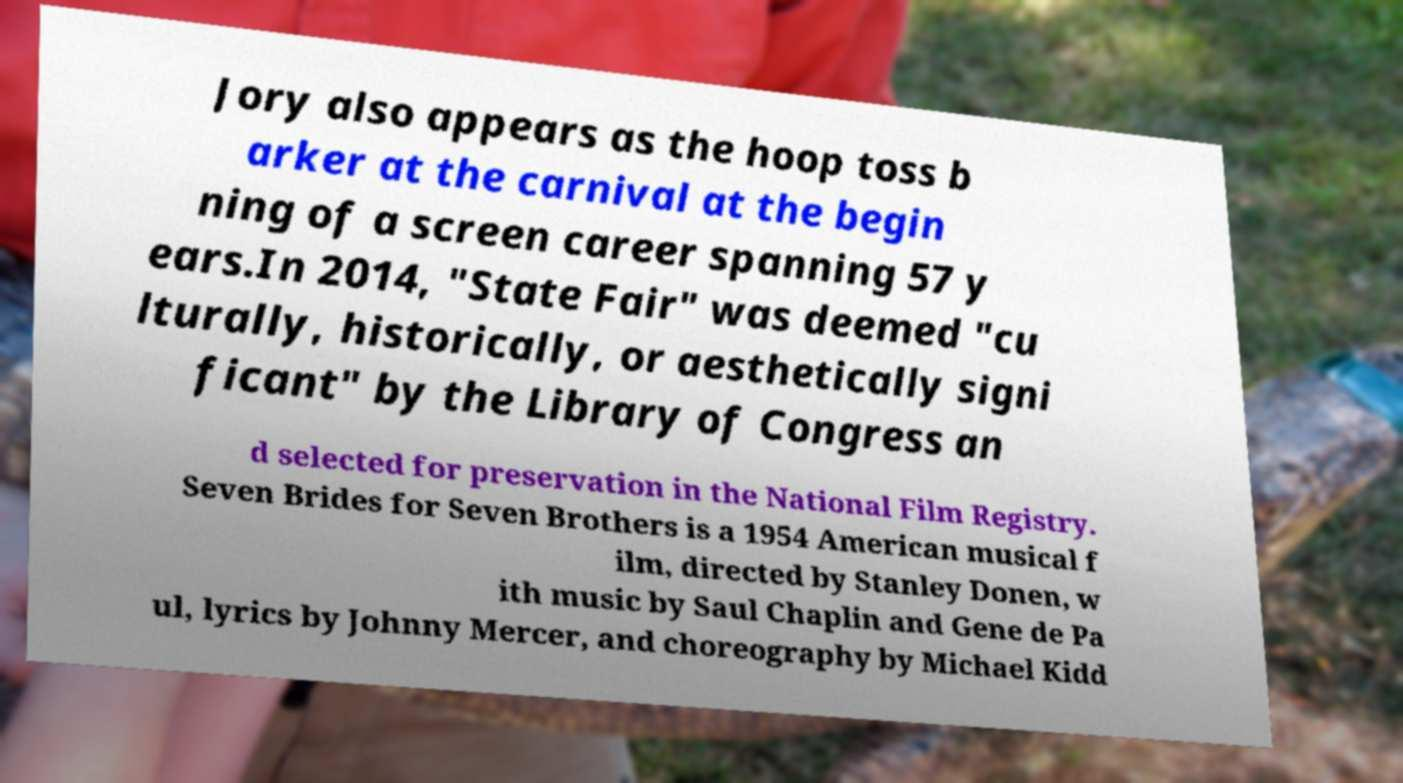What messages or text are displayed in this image? I need them in a readable, typed format. Jory also appears as the hoop toss b arker at the carnival at the begin ning of a screen career spanning 57 y ears.In 2014, "State Fair" was deemed "cu lturally, historically, or aesthetically signi ficant" by the Library of Congress an d selected for preservation in the National Film Registry. Seven Brides for Seven Brothers is a 1954 American musical f ilm, directed by Stanley Donen, w ith music by Saul Chaplin and Gene de Pa ul, lyrics by Johnny Mercer, and choreography by Michael Kidd 